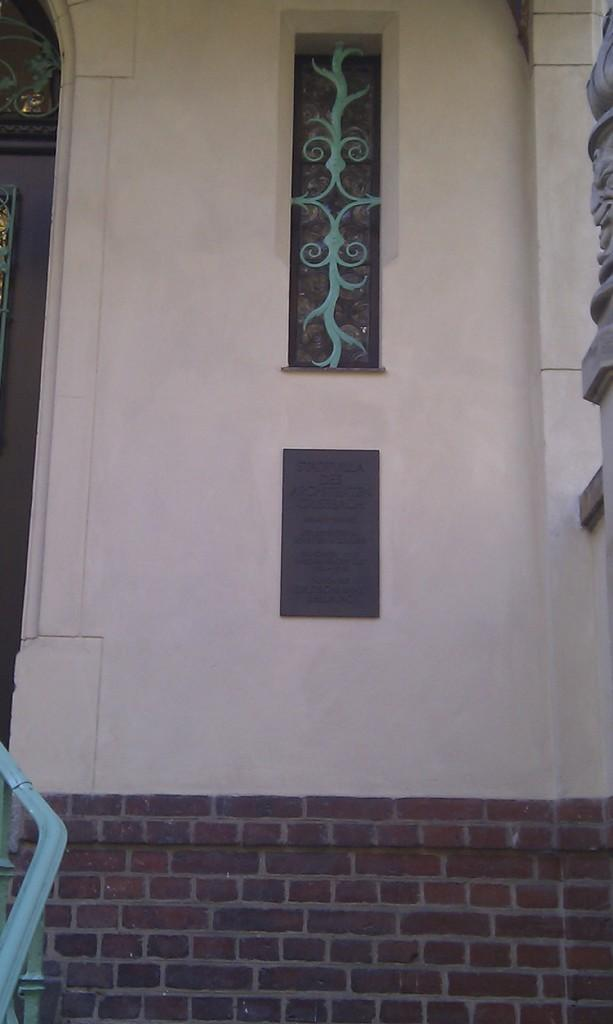What is a prominent feature on the wall in the image? There is a window fixed to the wall in the image. What other feature can be seen on the wall? There is a door on the left side of the wall. Can you describe the wall in the image? The wall has a window and a door on it. What question is the father asking in the image? There is no father or question present in the image; it only features a wall with a window and a door. 